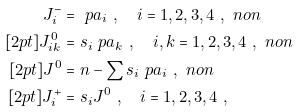Convert formula to latex. <formula><loc_0><loc_0><loc_500><loc_500>J _ { i } ^ { - } & = \ p a _ { i } \ , \quad i = 1 , 2 , 3 , 4 \ , \ n o n \\ [ 2 p t ] J _ { i k } ^ { 0 } & = s _ { i } \ p a _ { k } \ , \quad i , k = 1 , 2 , 3 , 4 \ , \ n o n \\ [ 2 p t ] J ^ { 0 } & = n - \sum s _ { i } \ p a _ { i } \ , \ n o n \\ [ 2 p t ] J _ { i } ^ { + } & = s _ { i } J ^ { 0 } \ , \quad i = 1 , 2 , 3 , 4 \ ,</formula> 